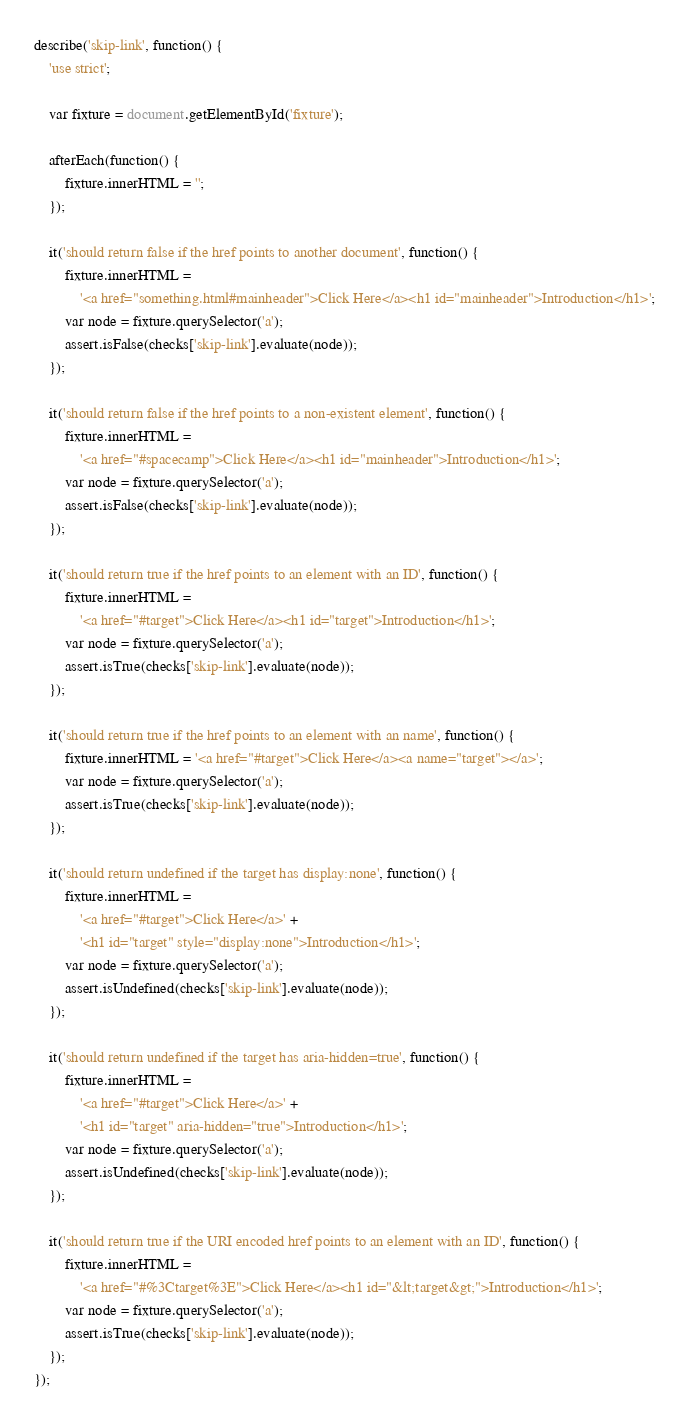<code> <loc_0><loc_0><loc_500><loc_500><_JavaScript_>describe('skip-link', function() {
	'use strict';

	var fixture = document.getElementById('fixture');

	afterEach(function() {
		fixture.innerHTML = '';
	});

	it('should return false if the href points to another document', function() {
		fixture.innerHTML =
			'<a href="something.html#mainheader">Click Here</a><h1 id="mainheader">Introduction</h1>';
		var node = fixture.querySelector('a');
		assert.isFalse(checks['skip-link'].evaluate(node));
	});

	it('should return false if the href points to a non-existent element', function() {
		fixture.innerHTML =
			'<a href="#spacecamp">Click Here</a><h1 id="mainheader">Introduction</h1>';
		var node = fixture.querySelector('a');
		assert.isFalse(checks['skip-link'].evaluate(node));
	});

	it('should return true if the href points to an element with an ID', function() {
		fixture.innerHTML =
			'<a href="#target">Click Here</a><h1 id="target">Introduction</h1>';
		var node = fixture.querySelector('a');
		assert.isTrue(checks['skip-link'].evaluate(node));
	});

	it('should return true if the href points to an element with an name', function() {
		fixture.innerHTML = '<a href="#target">Click Here</a><a name="target"></a>';
		var node = fixture.querySelector('a');
		assert.isTrue(checks['skip-link'].evaluate(node));
	});

	it('should return undefined if the target has display:none', function() {
		fixture.innerHTML =
			'<a href="#target">Click Here</a>' +
			'<h1 id="target" style="display:none">Introduction</h1>';
		var node = fixture.querySelector('a');
		assert.isUndefined(checks['skip-link'].evaluate(node));
	});

	it('should return undefined if the target has aria-hidden=true', function() {
		fixture.innerHTML =
			'<a href="#target">Click Here</a>' +
			'<h1 id="target" aria-hidden="true">Introduction</h1>';
		var node = fixture.querySelector('a');
		assert.isUndefined(checks['skip-link'].evaluate(node));
	});

	it('should return true if the URI encoded href points to an element with an ID', function() {
		fixture.innerHTML =
			'<a href="#%3Ctarget%3E">Click Here</a><h1 id="&lt;target&gt;">Introduction</h1>';
		var node = fixture.querySelector('a');
		assert.isTrue(checks['skip-link'].evaluate(node));
	});
});
</code> 